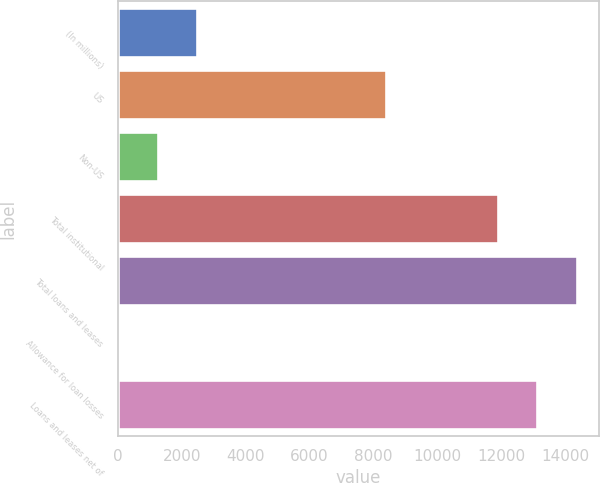Convert chart. <chart><loc_0><loc_0><loc_500><loc_500><bar_chart><fcel>(In millions)<fcel>US<fcel>Non-US<fcel>Total institutional<fcel>Total loans and leases<fcel>Allowance for loan losses<fcel>Loans and leases net of<nl><fcel>2479<fcel>8376<fcel>1250.5<fcel>11896<fcel>14353<fcel>22<fcel>13124.5<nl></chart> 